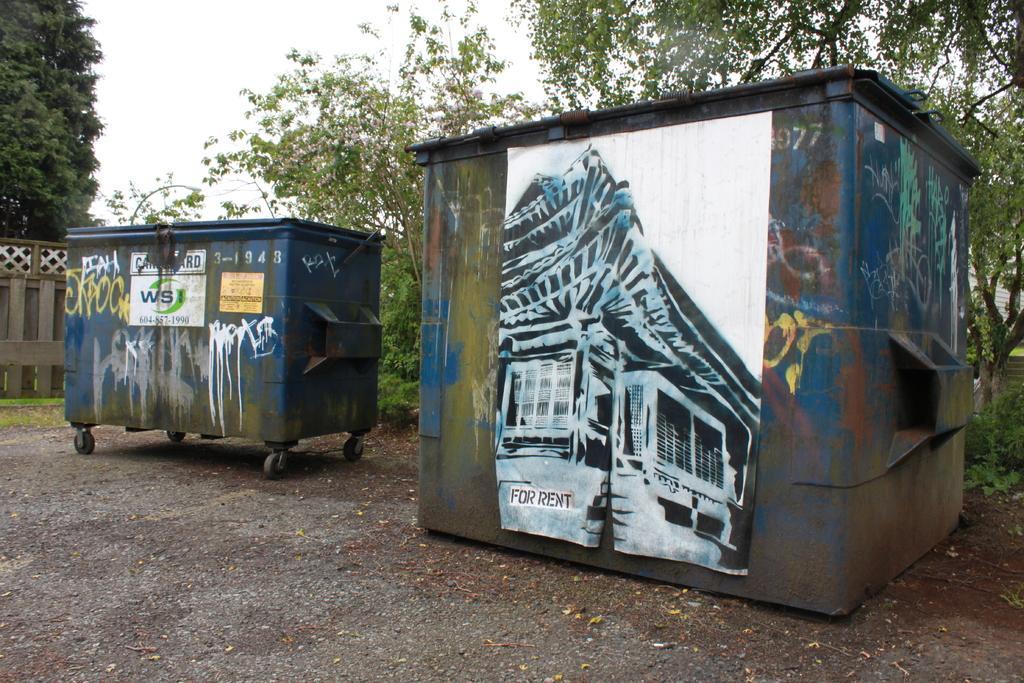Please provide a concise description of this image. In this picture there is a blue box which has a picture attached on it and there is something written beside it and there is another box beside it and there are few trees behind it and there is a fence wall and a tree in the left corner. 